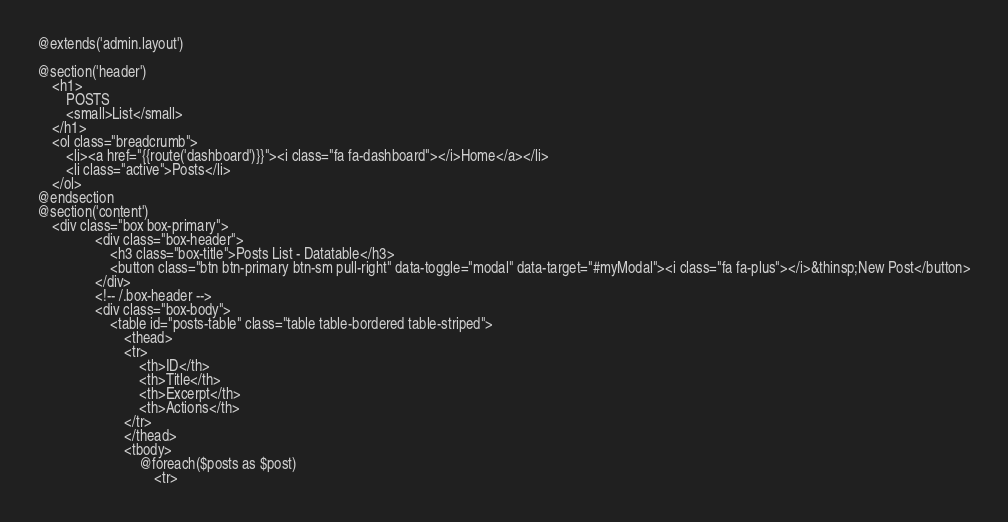Convert code to text. <code><loc_0><loc_0><loc_500><loc_500><_PHP_>@extends('admin.layout')

@section('header')
	<h1>
		POSTS
		<small>List</small>
	</h1>
	<ol class="breadcrumb">
		<li><a href="{{route('dashboard')}}"><i class="fa fa-dashboard"></i>Home</a></li>
		<li class="active">Posts</li>
	</ol>
@endsection
@section('content')
	<div class="box box-primary">
				<div class="box-header">
					<h3 class="box-title">Posts List - Datatable</h3>
					<button class="btn btn-primary btn-sm pull-right" data-toggle="modal" data-target="#myModal"><i class="fa fa-plus"></i>&thinsp;New Post</button>
				</div>
				<!-- /.box-header -->
				<div class="box-body">
					<table id="posts-table" class="table table-bordered table-striped">
						<thead>
						<tr>
							<th>ID</th>
							<th>Title</th>
							<th>Excerpt</th>
							<th>Actions</th>
						</tr>
						</thead>
						<tbody>
							@foreach($posts as $post)
								<tr></code> 